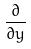<formula> <loc_0><loc_0><loc_500><loc_500>\frac { \partial } { \partial y }</formula> 